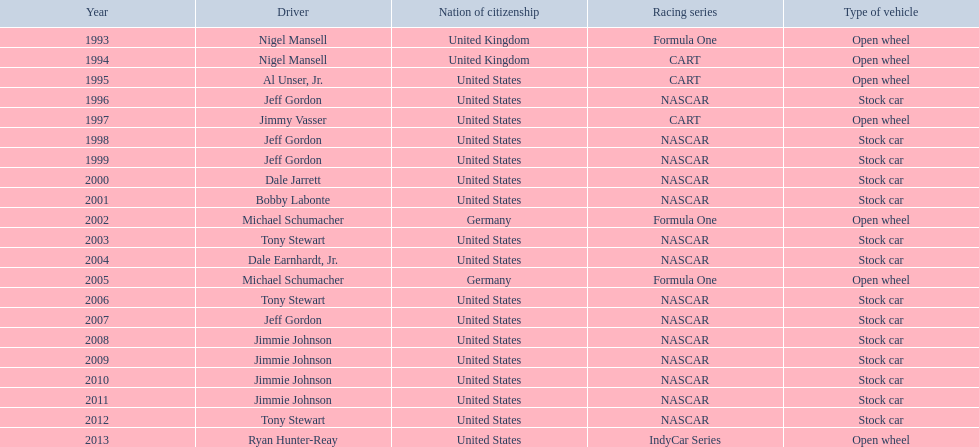Which drivers have secured the best driver espy award? Nigel Mansell, Nigel Mansell, Al Unser, Jr., Jeff Gordon, Jimmy Vasser, Jeff Gordon, Jeff Gordon, Dale Jarrett, Bobby Labonte, Michael Schumacher, Tony Stewart, Dale Earnhardt, Jr., Michael Schumacher, Tony Stewart, Jeff Gordon, Jimmie Johnson, Jimmie Johnson, Jimmie Johnson, Jimmie Johnson, Tony Stewart, Ryan Hunter-Reay. Out of these, who only feature once? Al Unser, Jr., Jimmy Vasser, Dale Jarrett, Dale Earnhardt, Jr., Ryan Hunter-Reay. Which ones belong to the cart racing series? Al Unser, Jr., Jimmy Vasser. Among these, who obtained their award first? Al Unser, Jr. 